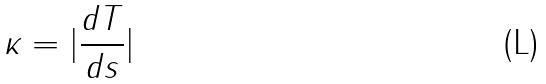<formula> <loc_0><loc_0><loc_500><loc_500>\kappa = | \frac { d T } { d s } |</formula> 